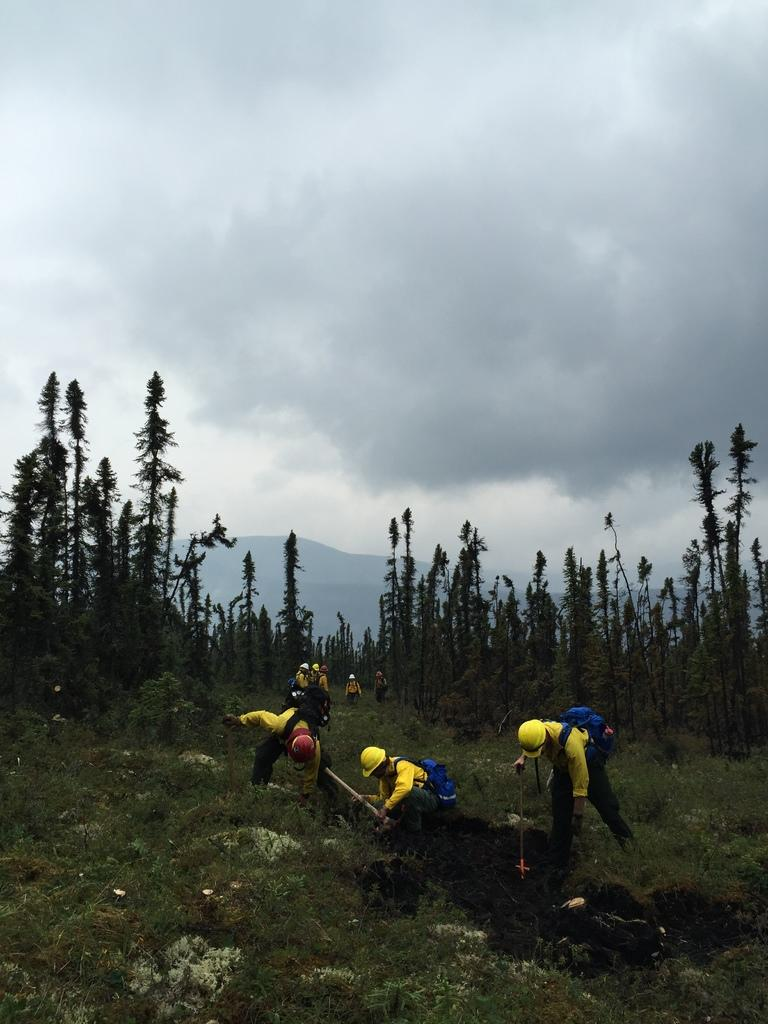Who or what can be seen in the image? There are people in the image. What type of natural environment is visible in the image? There is grass visible in the image. What can be seen in the background of the image? There are trees and clouds in the sky in the background of the image. What type of news is being reported by the fog in the image? There is no fog present in the image, and therefore no news being reported by it. 